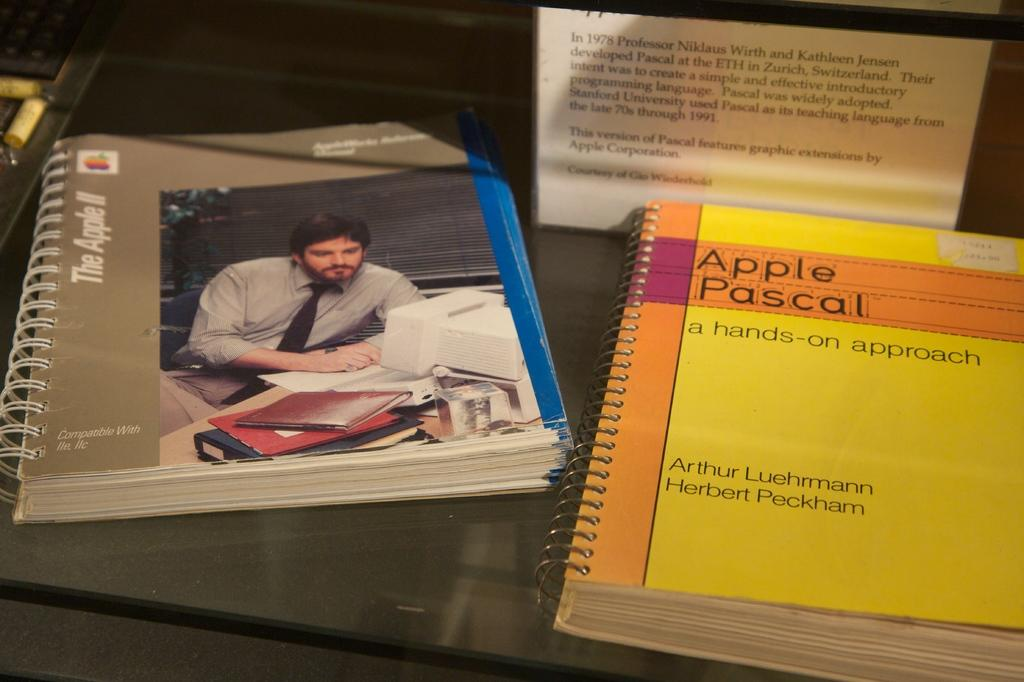<image>
Summarize the visual content of the image. Yellow and orange booklet that says "Apple Pascal" on it. 